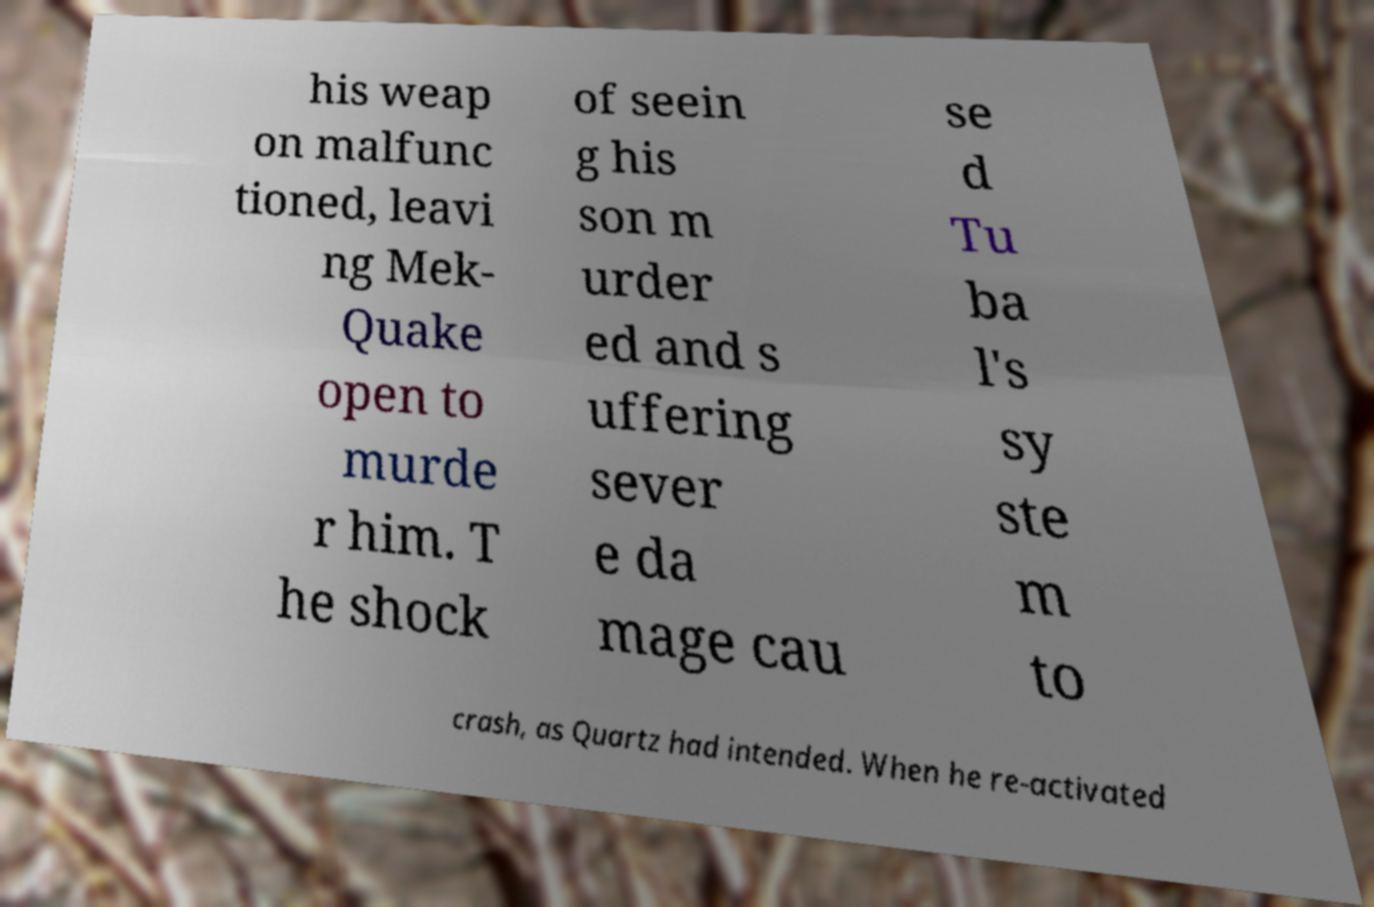For documentation purposes, I need the text within this image transcribed. Could you provide that? his weap on malfunc tioned, leavi ng Mek- Quake open to murde r him. T he shock of seein g his son m urder ed and s uffering sever e da mage cau se d Tu ba l's sy ste m to crash, as Quartz had intended. When he re-activated 